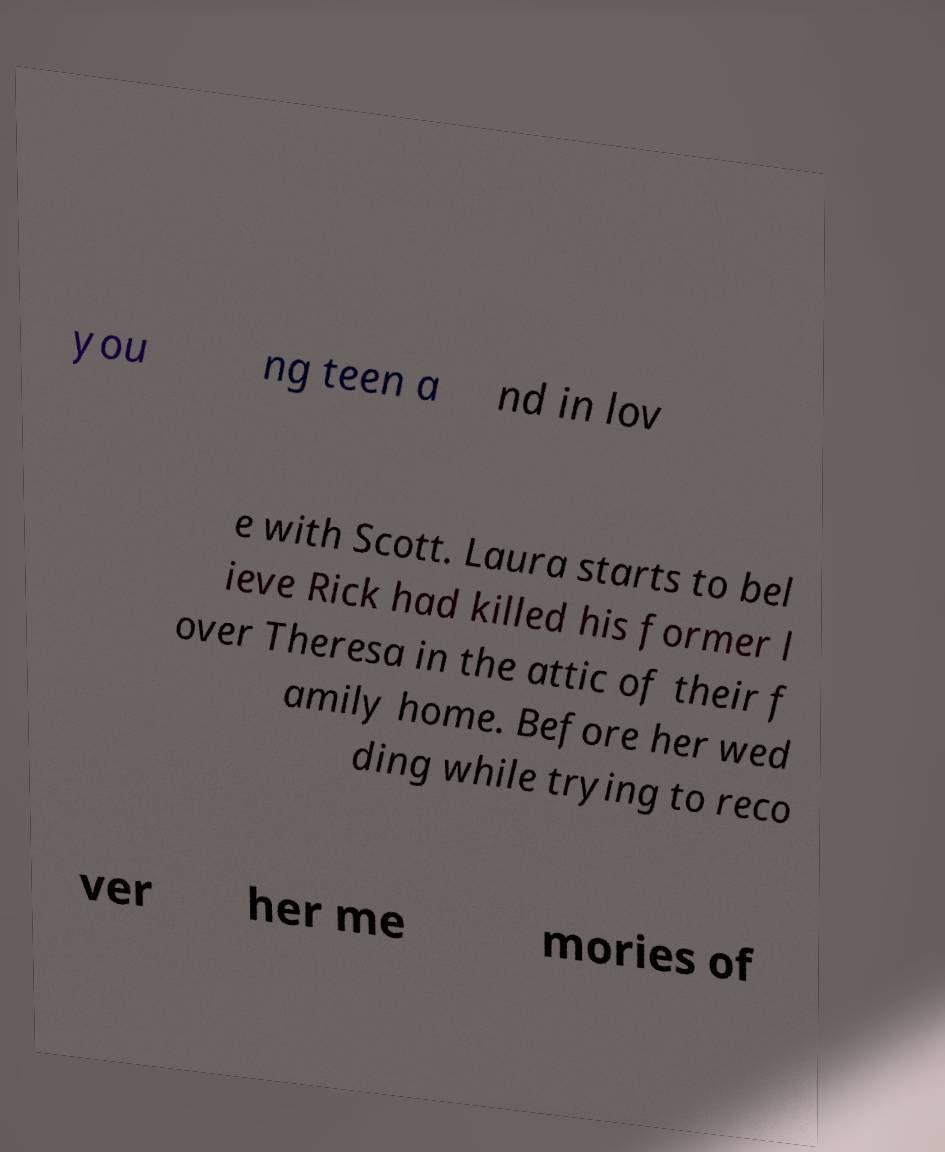For documentation purposes, I need the text within this image transcribed. Could you provide that? you ng teen a nd in lov e with Scott. Laura starts to bel ieve Rick had killed his former l over Theresa in the attic of their f amily home. Before her wed ding while trying to reco ver her me mories of 